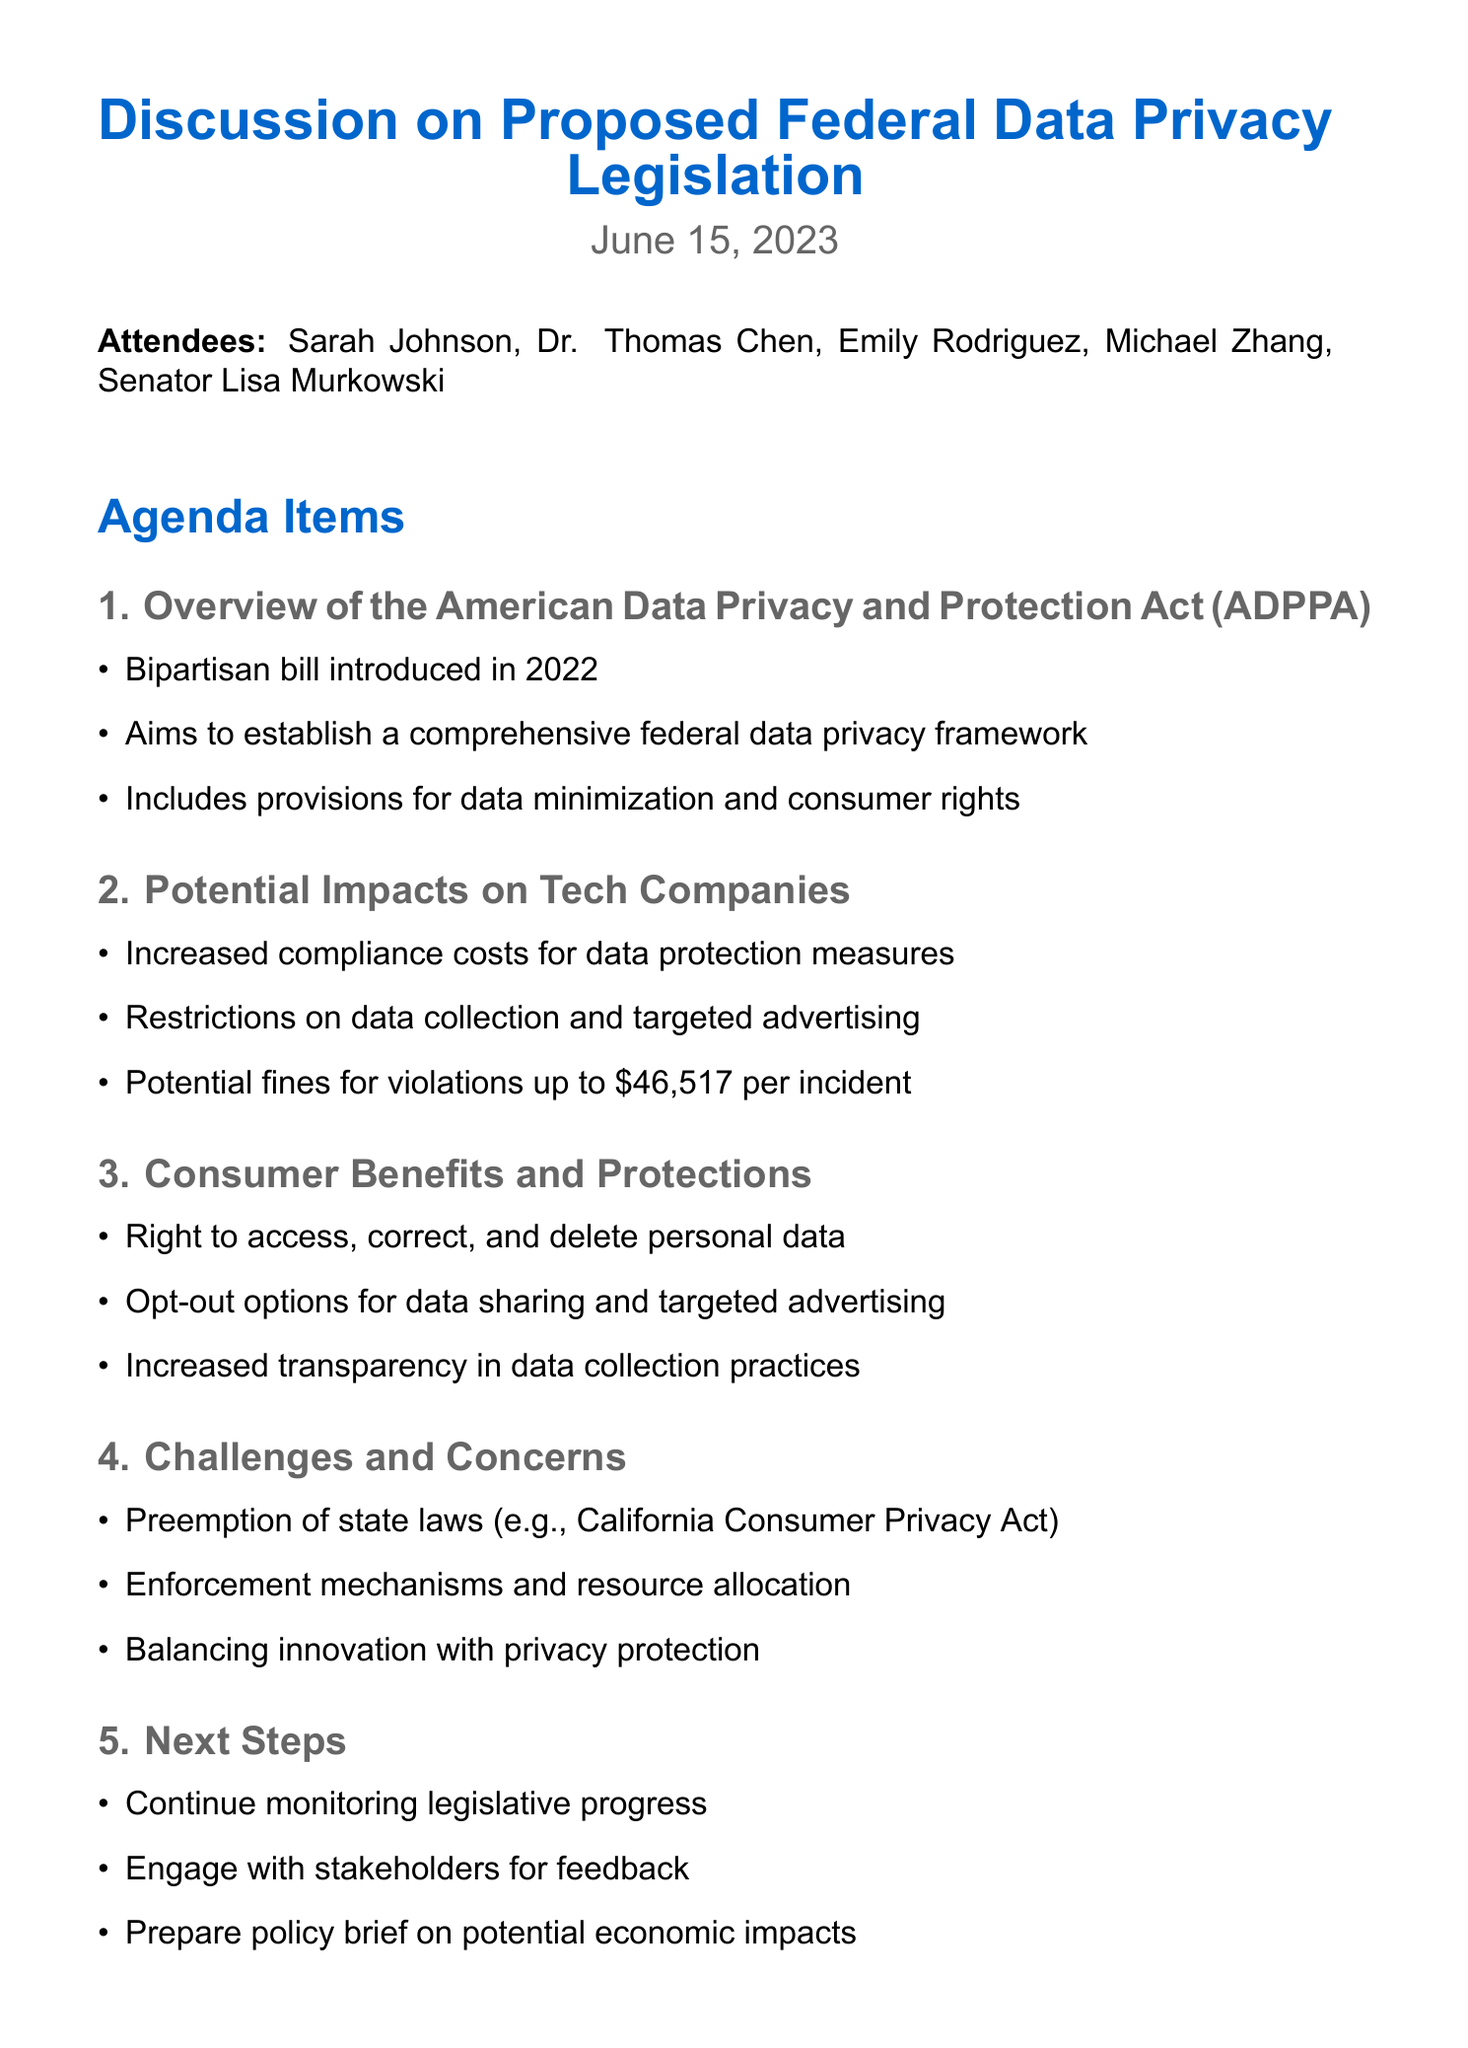What is the date of the meeting? The date of the meeting is clearly stated in the document as June 15, 2023.
Answer: June 15, 2023 Who is the representative from the Electronic Frontier Foundation? The document lists Emily Rodriguez as the representative from the Electronic Frontier Foundation.
Answer: Emily Rodriguez What is one provision included in the ADPPA? The document mentions "data minimization" as one of the provisions included in the ADPPA.
Answer: Data minimization What is the potential fine for violations mentioned in the document? The document specifies that the potential fines can be up to $46,517 per incident.
Answer: $46,517 What is one challenge associated with the proposed legislation? The document highlights "preemption of state laws" as one challenge associated with the proposed legislation.
Answer: Preemption of state laws Who will draft a summary report on the discussion? The action items indicate that Sarah Johnson is responsible for drafting a summary report on the discussion.
Answer: Sarah Johnson What is one consumer right mentioned in the benefits section? The document states that consumers have the right to access their personal data.
Answer: Access personal data What is one of the next steps outlined in the meeting minutes? One of the next steps is to "engage with stakeholders for feedback," as listed in the document.
Answer: Engage with stakeholders for feedback How many attendees were present at the meeting? The document lists five attendees in total, providing their names and affiliations.
Answer: Five 